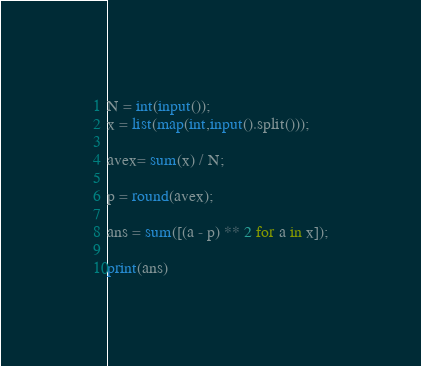<code> <loc_0><loc_0><loc_500><loc_500><_Python_>N = int(input());
x = list(map(int,input().split()));

avex= sum(x) / N;

p = round(avex);

ans = sum([(a - p) ** 2 for a in x]);

print(ans)
</code> 